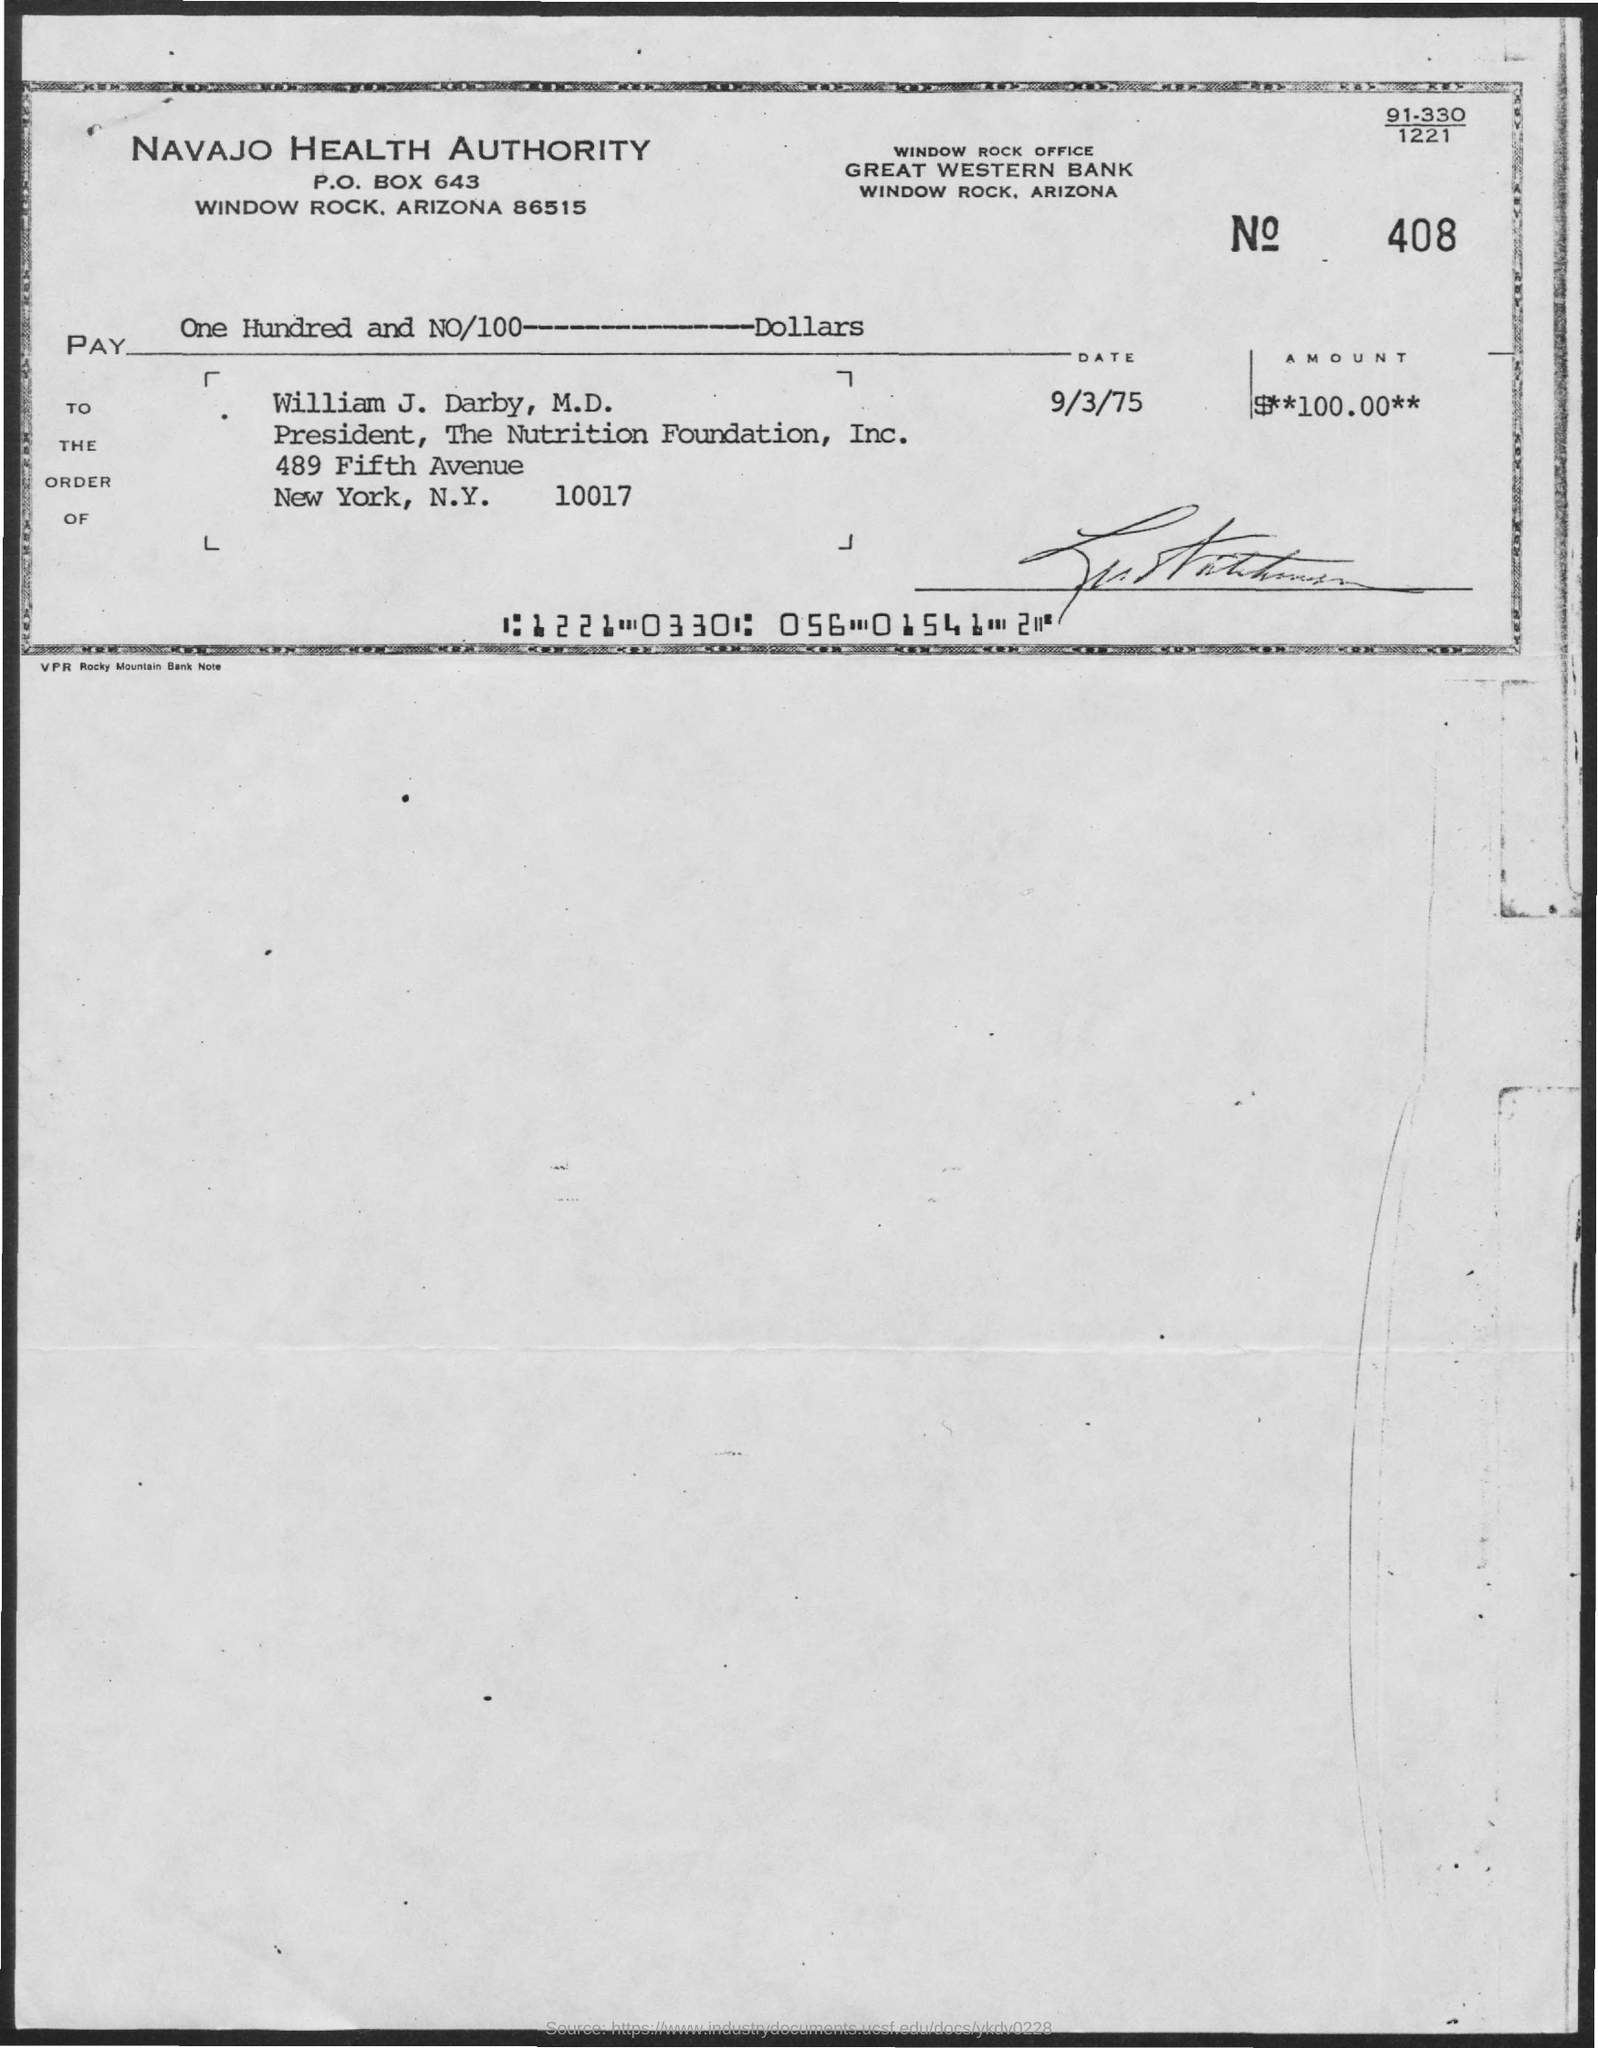What is the date mentioned in the check?
Your response must be concise. 9/3/75. What is the amount of check given?
Keep it short and to the point. $**100.00**. In whose name, the check is issued?
Give a very brief answer. William J. Darby, M.D. What is the designation of William J. Darby, M.D.?
Offer a terse response. President, The Nutrition Foundation, Inc. Which bank has issued this check?
Provide a short and direct response. GREAT WESTERN BANK. 